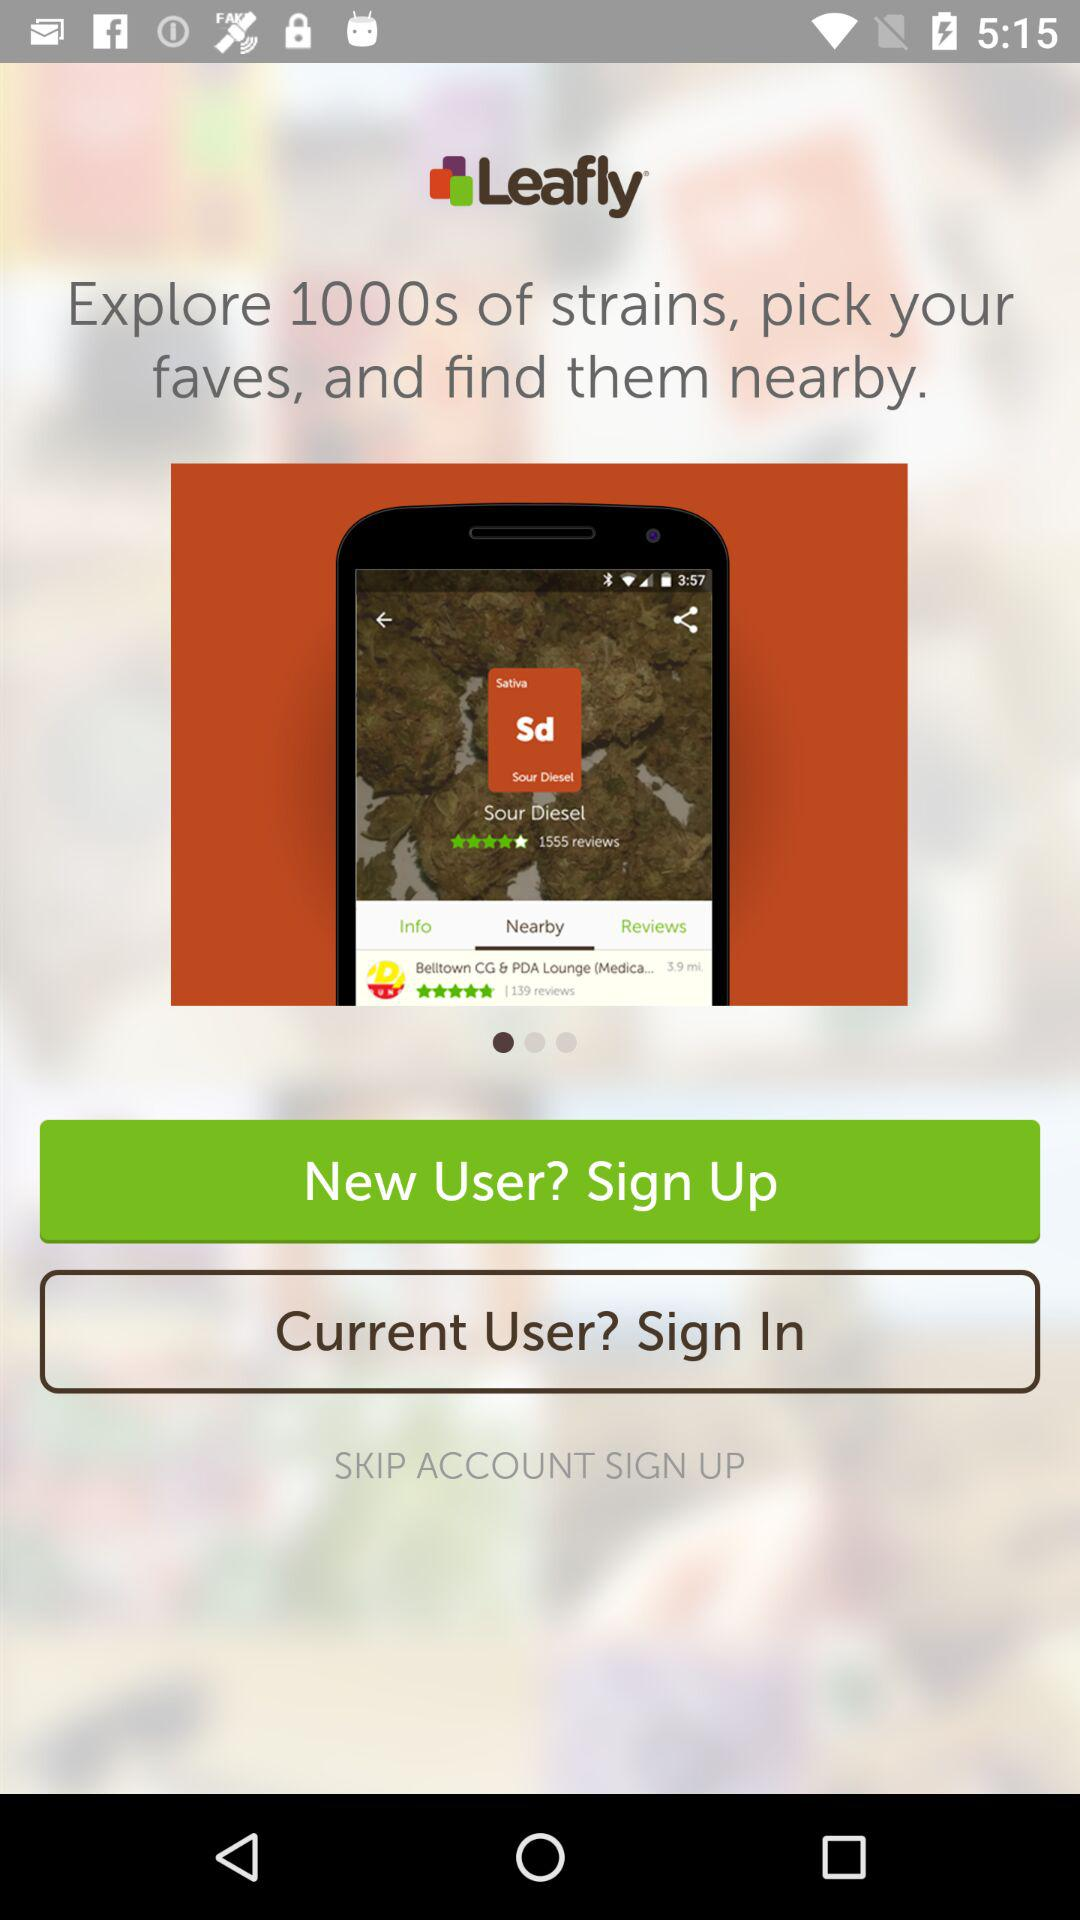How many strains are explored? There are 1000s of explored strains. 